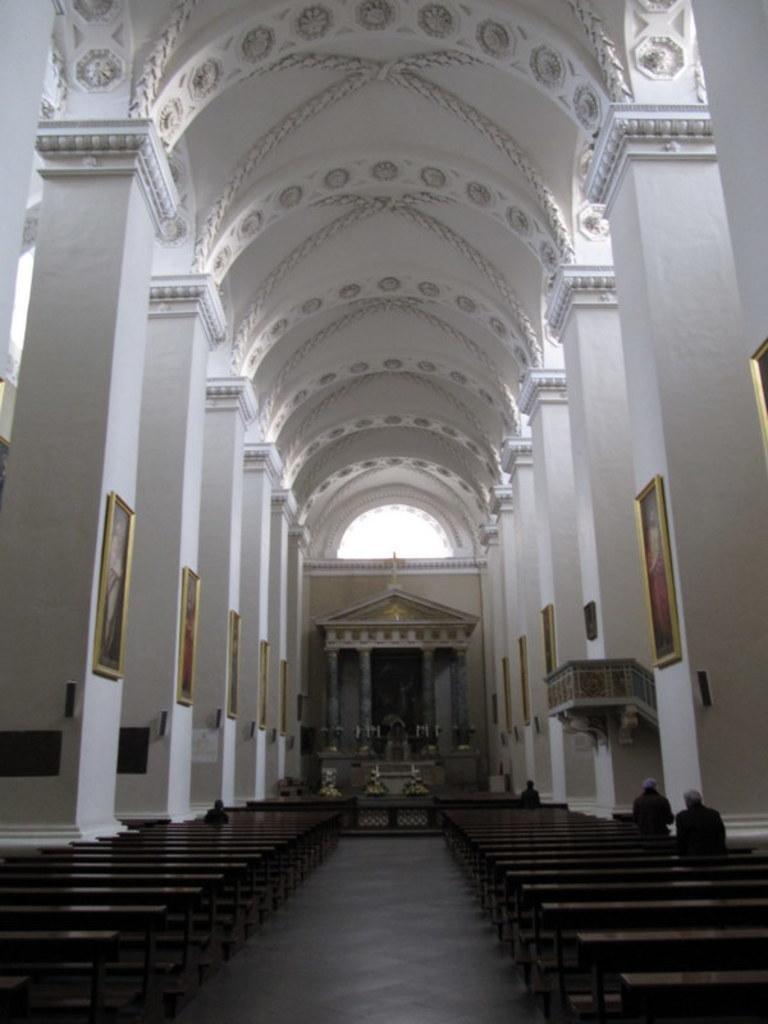How would you summarize this image in a sentence or two? in this image we can see inside view of a building. In the foreground we can see a group of chairs and to the right side of the image we can see some persons standing. In the background, we can see photo frames on walls, pillars and window. 